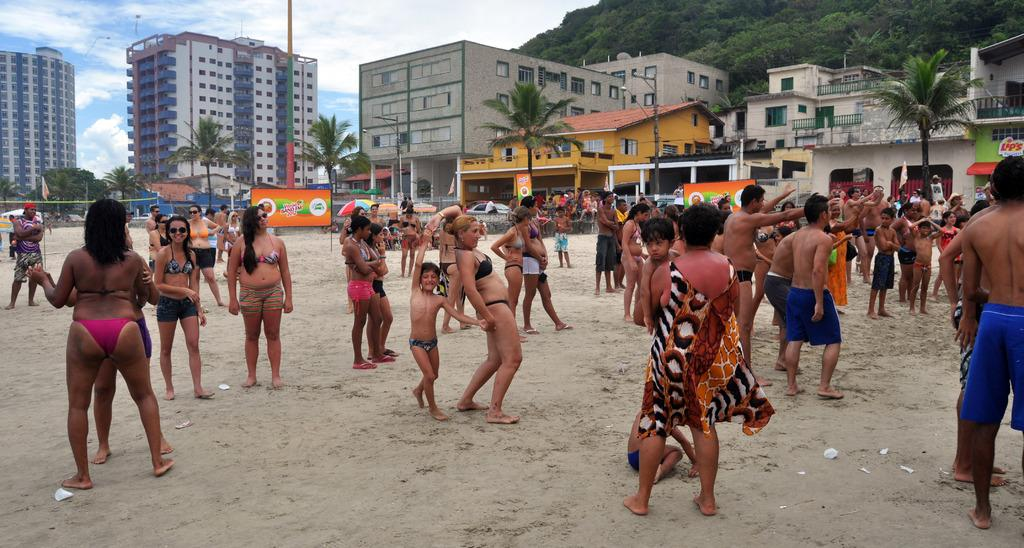What is happening with the group of people in the image? The group of people is on the ground. What can be seen in the background of the image? There are buildings, trees, boards, and the sky visible in the background of the image. Can you describe the unspecified objects in the background? Unfortunately, the provided facts do not specify the nature of the unspecified objects in the background. How does the group of people hear the sound of the lumber in the image? There is no mention of lumber or any sound in the image, so it is not possible to answer this question. 